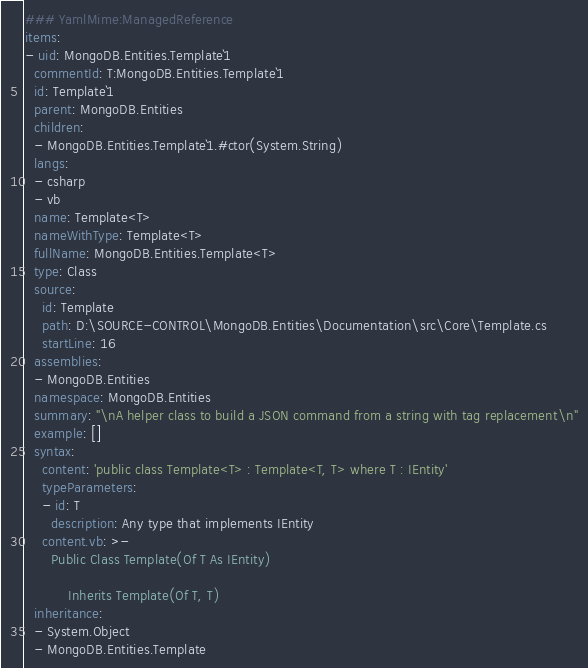Convert code to text. <code><loc_0><loc_0><loc_500><loc_500><_YAML_>### YamlMime:ManagedReference
items:
- uid: MongoDB.Entities.Template`1
  commentId: T:MongoDB.Entities.Template`1
  id: Template`1
  parent: MongoDB.Entities
  children:
  - MongoDB.Entities.Template`1.#ctor(System.String)
  langs:
  - csharp
  - vb
  name: Template<T>
  nameWithType: Template<T>
  fullName: MongoDB.Entities.Template<T>
  type: Class
  source:
    id: Template
    path: D:\SOURCE-CONTROL\MongoDB.Entities\Documentation\src\Core\Template.cs
    startLine: 16
  assemblies:
  - MongoDB.Entities
  namespace: MongoDB.Entities
  summary: "\nA helper class to build a JSON command from a string with tag replacement\n"
  example: []
  syntax:
    content: 'public class Template<T> : Template<T, T> where T : IEntity'
    typeParameters:
    - id: T
      description: Any type that implements IEntity
    content.vb: >-
      Public Class Template(Of T As IEntity)

          Inherits Template(Of T, T)
  inheritance:
  - System.Object
  - MongoDB.Entities.Template</code> 